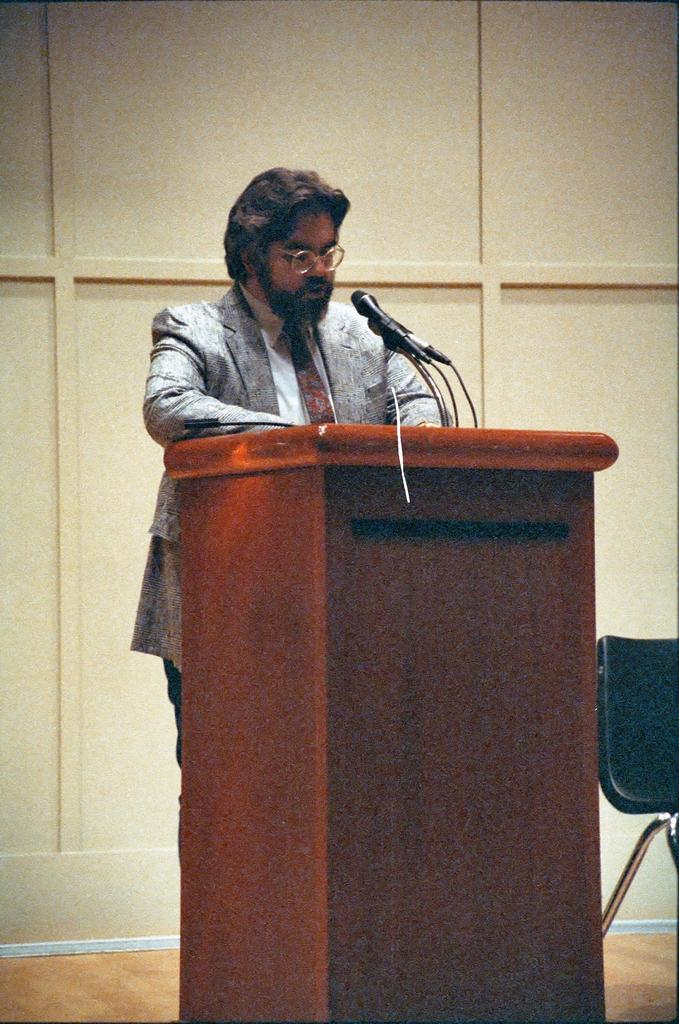What is the main subject of the image? There is a man standing in the image. What objects are in front of the man? Microphones are above a podium in front of the man. What piece of furniture is beside the podium? A chair is beside the podium. What is visible in the background of the image? There is a wall in the background of the image. How many houses are visible in the image? There are no houses visible in the image. What type of throat condition does the man have in the image? There is no information about the man's throat condition in the image. 